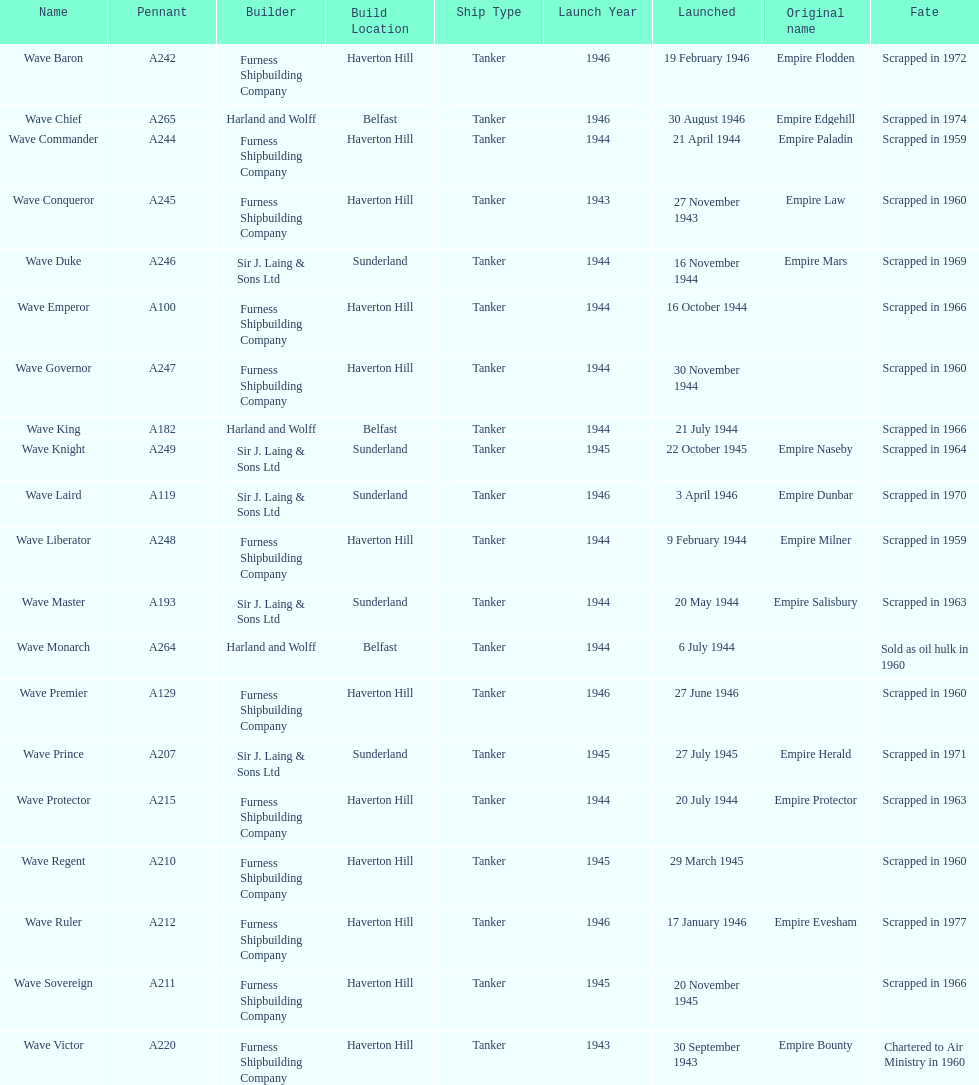What was the subsequent wave class oiler following wave emperor? Wave Duke. 